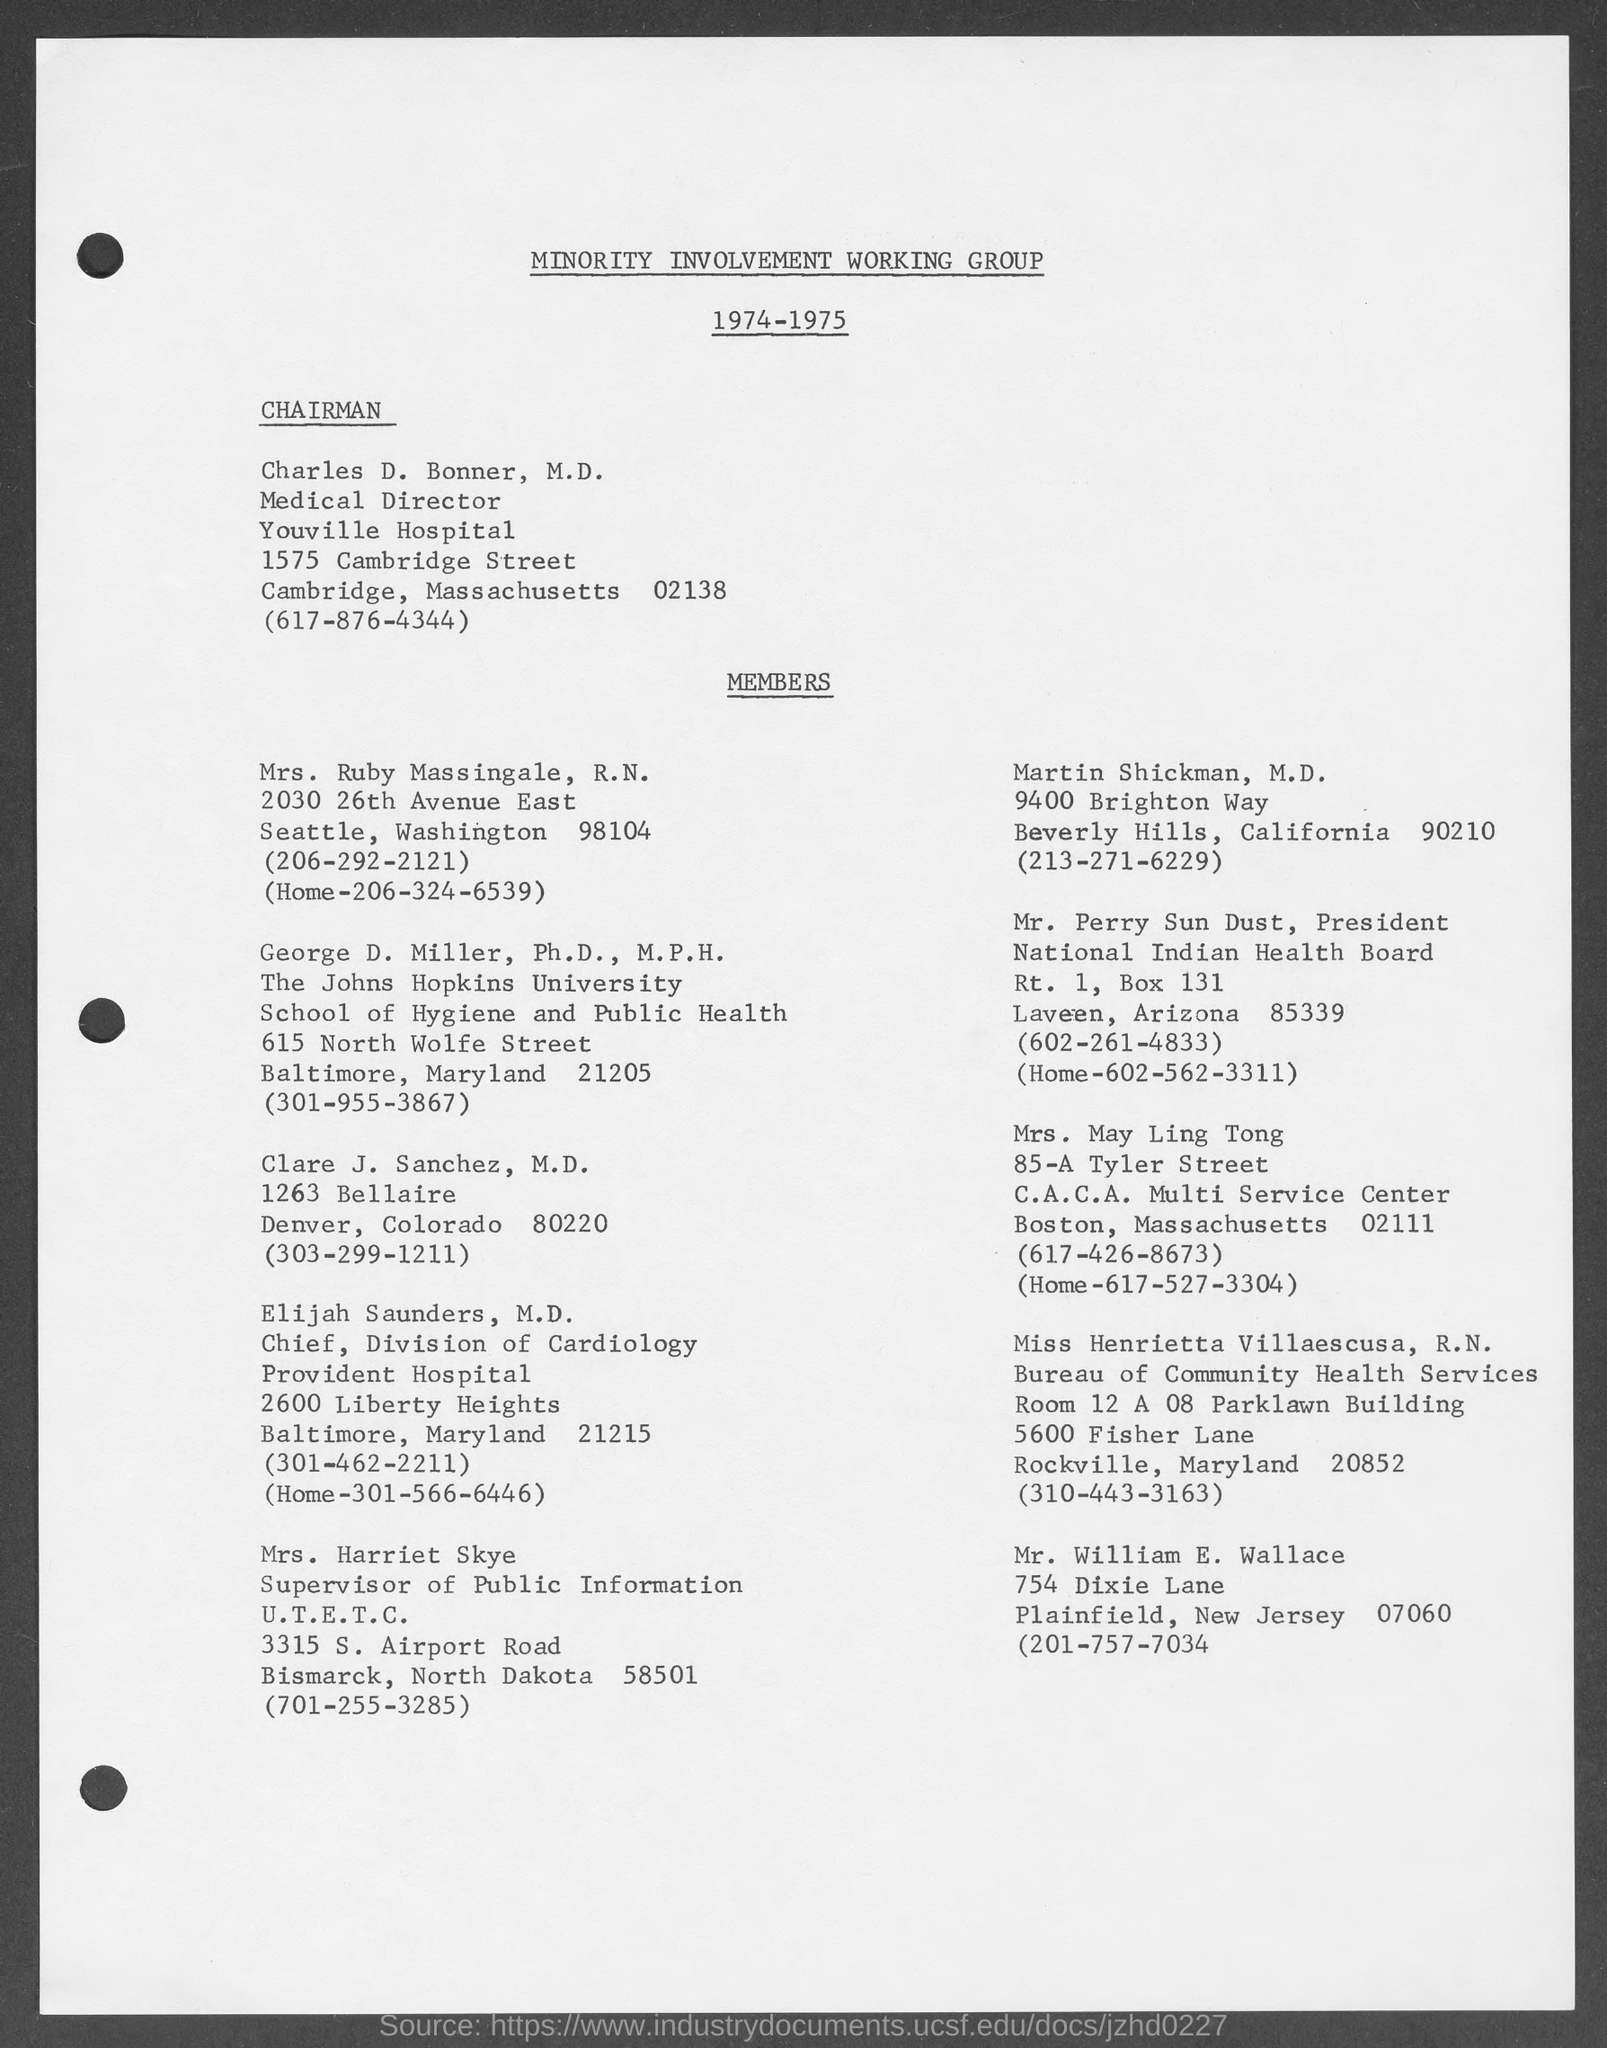What is the name of the working group mentioned in the given page ?
Ensure brevity in your answer.  MINORITY INVOLVEMENT WORKING GROUP. To which university george d. miller , belongs to ?
Provide a short and direct response. The Johns Hopkins university. 